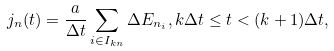<formula> <loc_0><loc_0><loc_500><loc_500>j _ { n } ( t ) = \frac { a } { \Delta t } \sum _ { i \in I _ { k n } } \Delta E _ { n _ { i } } , k \Delta t \leq t < ( k + 1 ) \Delta t ,</formula> 